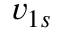<formula> <loc_0><loc_0><loc_500><loc_500>v _ { 1 s }</formula> 